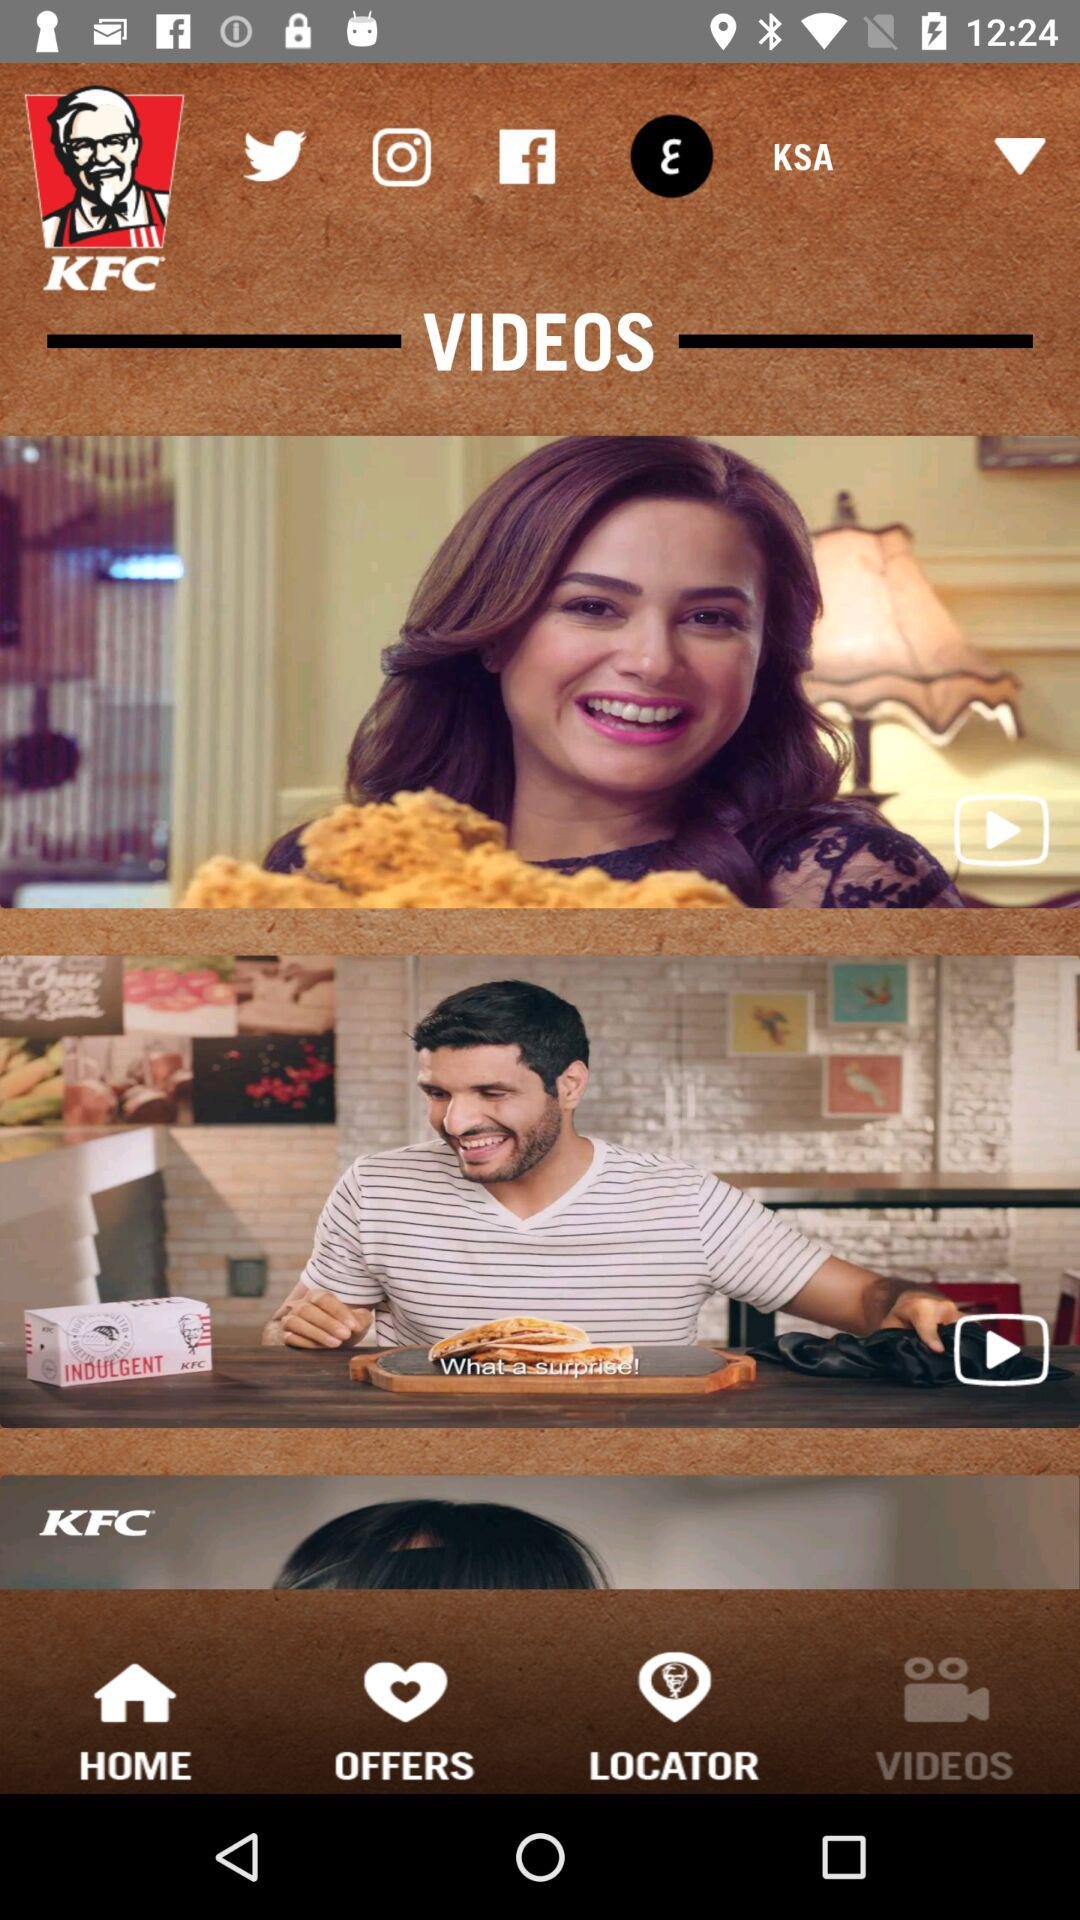Which tab am I using? You are using the "VIDEOS" tab. 